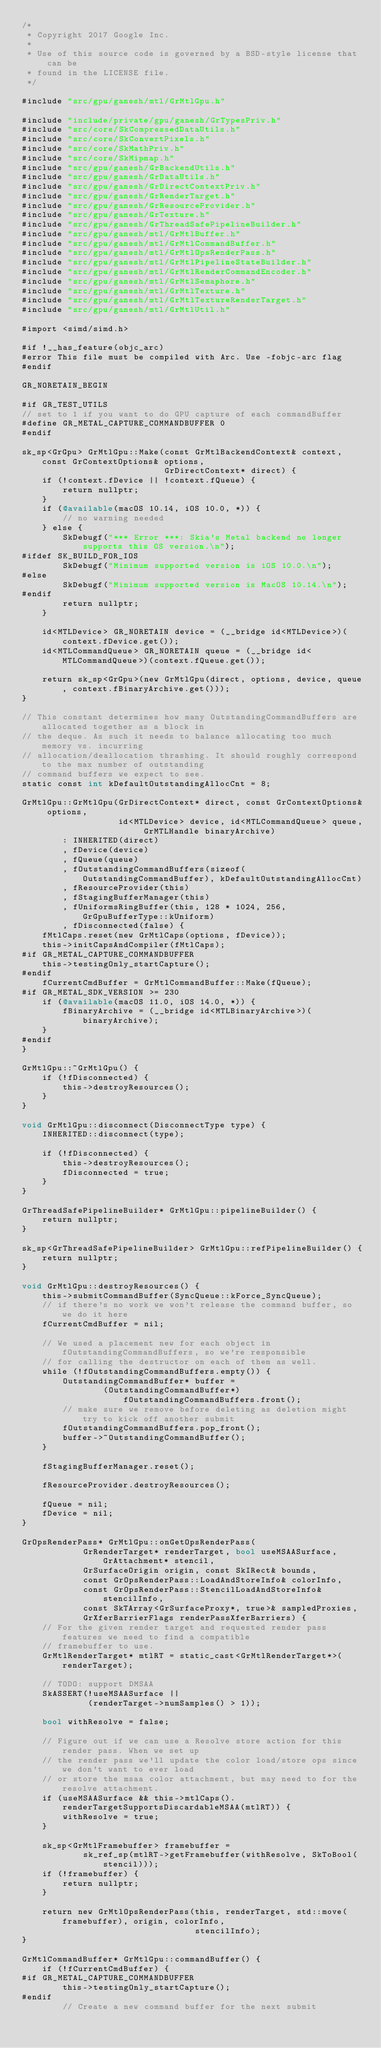Convert code to text. <code><loc_0><loc_0><loc_500><loc_500><_ObjectiveC_>/*
 * Copyright 2017 Google Inc.
 *
 * Use of this source code is governed by a BSD-style license that can be
 * found in the LICENSE file.
 */

#include "src/gpu/ganesh/mtl/GrMtlGpu.h"

#include "include/private/gpu/ganesh/GrTypesPriv.h"
#include "src/core/SkCompressedDataUtils.h"
#include "src/core/SkConvertPixels.h"
#include "src/core/SkMathPriv.h"
#include "src/core/SkMipmap.h"
#include "src/gpu/ganesh/GrBackendUtils.h"
#include "src/gpu/ganesh/GrDataUtils.h"
#include "src/gpu/ganesh/GrDirectContextPriv.h"
#include "src/gpu/ganesh/GrRenderTarget.h"
#include "src/gpu/ganesh/GrResourceProvider.h"
#include "src/gpu/ganesh/GrTexture.h"
#include "src/gpu/ganesh/GrThreadSafePipelineBuilder.h"
#include "src/gpu/ganesh/mtl/GrMtlBuffer.h"
#include "src/gpu/ganesh/mtl/GrMtlCommandBuffer.h"
#include "src/gpu/ganesh/mtl/GrMtlOpsRenderPass.h"
#include "src/gpu/ganesh/mtl/GrMtlPipelineStateBuilder.h"
#include "src/gpu/ganesh/mtl/GrMtlRenderCommandEncoder.h"
#include "src/gpu/ganesh/mtl/GrMtlSemaphore.h"
#include "src/gpu/ganesh/mtl/GrMtlTexture.h"
#include "src/gpu/ganesh/mtl/GrMtlTextureRenderTarget.h"
#include "src/gpu/ganesh/mtl/GrMtlUtil.h"

#import <simd/simd.h>

#if !__has_feature(objc_arc)
#error This file must be compiled with Arc. Use -fobjc-arc flag
#endif

GR_NORETAIN_BEGIN

#if GR_TEST_UTILS
// set to 1 if you want to do GPU capture of each commandBuffer
#define GR_METAL_CAPTURE_COMMANDBUFFER 0
#endif

sk_sp<GrGpu> GrMtlGpu::Make(const GrMtlBackendContext& context, const GrContextOptions& options,
                            GrDirectContext* direct) {
    if (!context.fDevice || !context.fQueue) {
        return nullptr;
    }
    if (@available(macOS 10.14, iOS 10.0, *)) {
        // no warning needed
    } else {
        SkDebugf("*** Error ***: Skia's Metal backend no longer supports this OS version.\n");
#ifdef SK_BUILD_FOR_IOS
        SkDebugf("Minimum supported version is iOS 10.0.\n");
#else
        SkDebugf("Minimum supported version is MacOS 10.14.\n");
#endif
        return nullptr;
    }

    id<MTLDevice> GR_NORETAIN device = (__bridge id<MTLDevice>)(context.fDevice.get());
    id<MTLCommandQueue> GR_NORETAIN queue = (__bridge id<MTLCommandQueue>)(context.fQueue.get());

    return sk_sp<GrGpu>(new GrMtlGpu(direct, options, device, queue, context.fBinaryArchive.get()));
}

// This constant determines how many OutstandingCommandBuffers are allocated together as a block in
// the deque. As such it needs to balance allocating too much memory vs. incurring
// allocation/deallocation thrashing. It should roughly correspond to the max number of outstanding
// command buffers we expect to see.
static const int kDefaultOutstandingAllocCnt = 8;

GrMtlGpu::GrMtlGpu(GrDirectContext* direct, const GrContextOptions& options,
                   id<MTLDevice> device, id<MTLCommandQueue> queue, GrMTLHandle binaryArchive)
        : INHERITED(direct)
        , fDevice(device)
        , fQueue(queue)
        , fOutstandingCommandBuffers(sizeof(OutstandingCommandBuffer), kDefaultOutstandingAllocCnt)
        , fResourceProvider(this)
        , fStagingBufferManager(this)
        , fUniformsRingBuffer(this, 128 * 1024, 256, GrGpuBufferType::kUniform)
        , fDisconnected(false) {
    fMtlCaps.reset(new GrMtlCaps(options, fDevice));
    this->initCapsAndCompiler(fMtlCaps);
#if GR_METAL_CAPTURE_COMMANDBUFFER
    this->testingOnly_startCapture();
#endif
    fCurrentCmdBuffer = GrMtlCommandBuffer::Make(fQueue);
#if GR_METAL_SDK_VERSION >= 230
    if (@available(macOS 11.0, iOS 14.0, *)) {
        fBinaryArchive = (__bridge id<MTLBinaryArchive>)(binaryArchive);
    }
#endif
}

GrMtlGpu::~GrMtlGpu() {
    if (!fDisconnected) {
        this->destroyResources();
    }
}

void GrMtlGpu::disconnect(DisconnectType type) {
    INHERITED::disconnect(type);

    if (!fDisconnected) {
        this->destroyResources();
        fDisconnected = true;
    }
}

GrThreadSafePipelineBuilder* GrMtlGpu::pipelineBuilder() {
    return nullptr;
}

sk_sp<GrThreadSafePipelineBuilder> GrMtlGpu::refPipelineBuilder() {
    return nullptr;
}

void GrMtlGpu::destroyResources() {
    this->submitCommandBuffer(SyncQueue::kForce_SyncQueue);
    // if there's no work we won't release the command buffer, so we do it here
    fCurrentCmdBuffer = nil;

    // We used a placement new for each object in fOutstandingCommandBuffers, so we're responsible
    // for calling the destructor on each of them as well.
    while (!fOutstandingCommandBuffers.empty()) {
        OutstandingCommandBuffer* buffer =
                (OutstandingCommandBuffer*)fOutstandingCommandBuffers.front();
        // make sure we remove before deleting as deletion might try to kick off another submit
        fOutstandingCommandBuffers.pop_front();
        buffer->~OutstandingCommandBuffer();
    }

    fStagingBufferManager.reset();

    fResourceProvider.destroyResources();

    fQueue = nil;
    fDevice = nil;
}

GrOpsRenderPass* GrMtlGpu::onGetOpsRenderPass(
            GrRenderTarget* renderTarget, bool useMSAASurface, GrAttachment* stencil,
            GrSurfaceOrigin origin, const SkIRect& bounds,
            const GrOpsRenderPass::LoadAndStoreInfo& colorInfo,
            const GrOpsRenderPass::StencilLoadAndStoreInfo& stencilInfo,
            const SkTArray<GrSurfaceProxy*, true>& sampledProxies,
            GrXferBarrierFlags renderPassXferBarriers) {
    // For the given render target and requested render pass features we need to find a compatible
    // framebuffer to use.
    GrMtlRenderTarget* mtlRT = static_cast<GrMtlRenderTarget*>(renderTarget);

    // TODO: support DMSAA
    SkASSERT(!useMSAASurface ||
             (renderTarget->numSamples() > 1));

    bool withResolve = false;

    // Figure out if we can use a Resolve store action for this render pass. When we set up
    // the render pass we'll update the color load/store ops since we don't want to ever load
    // or store the msaa color attachment, but may need to for the resolve attachment.
    if (useMSAASurface && this->mtlCaps().renderTargetSupportsDiscardableMSAA(mtlRT)) {
        withResolve = true;
    }

    sk_sp<GrMtlFramebuffer> framebuffer =
            sk_ref_sp(mtlRT->getFramebuffer(withResolve, SkToBool(stencil)));
    if (!framebuffer) {
        return nullptr;
    }

    return new GrMtlOpsRenderPass(this, renderTarget, std::move(framebuffer), origin, colorInfo,
                                  stencilInfo);
}

GrMtlCommandBuffer* GrMtlGpu::commandBuffer() {
    if (!fCurrentCmdBuffer) {
#if GR_METAL_CAPTURE_COMMANDBUFFER
        this->testingOnly_startCapture();
#endif
        // Create a new command buffer for the next submit</code> 